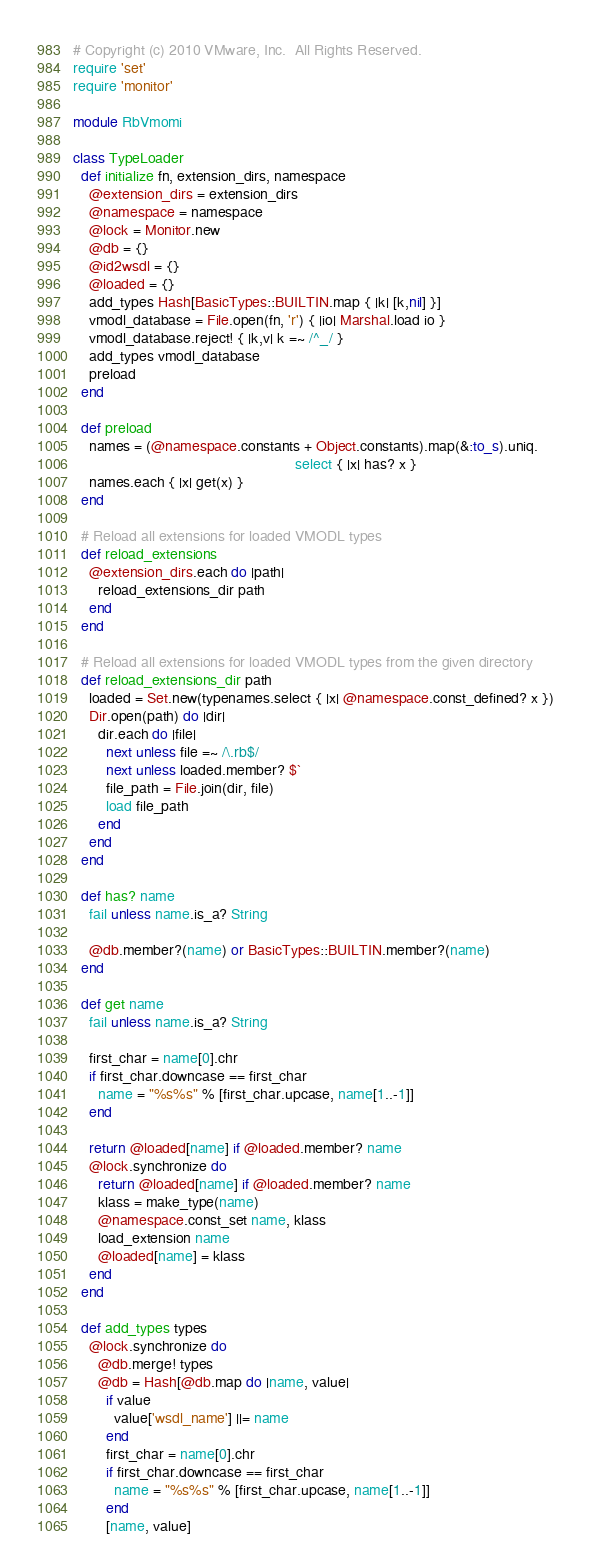Convert code to text. <code><loc_0><loc_0><loc_500><loc_500><_Ruby_># Copyright (c) 2010 VMware, Inc.  All Rights Reserved.
require 'set'
require 'monitor'

module RbVmomi

class TypeLoader
  def initialize fn, extension_dirs, namespace
    @extension_dirs = extension_dirs
    @namespace = namespace
    @lock = Monitor.new
    @db = {}
    @id2wsdl = {}
    @loaded = {}
    add_types Hash[BasicTypes::BUILTIN.map { |k| [k,nil] }]
    vmodl_database = File.open(fn, 'r') { |io| Marshal.load io }
    vmodl_database.reject! { |k,v| k =~ /^_/ }
    add_types vmodl_database
    preload
  end

  def preload
    names = (@namespace.constants + Object.constants).map(&:to_s).uniq.
                                                      select { |x| has? x }
    names.each { |x| get(x) }
  end

  # Reload all extensions for loaded VMODL types
  def reload_extensions
    @extension_dirs.each do |path|
      reload_extensions_dir path
    end
  end

  # Reload all extensions for loaded VMODL types from the given directory
  def reload_extensions_dir path
    loaded = Set.new(typenames.select { |x| @namespace.const_defined? x })
    Dir.open(path) do |dir|
      dir.each do |file|
        next unless file =~ /\.rb$/
        next unless loaded.member? $`
        file_path = File.join(dir, file)
        load file_path
      end
    end
  end

  def has? name
    fail unless name.is_a? String

    @db.member?(name) or BasicTypes::BUILTIN.member?(name)
  end

  def get name
    fail unless name.is_a? String

    first_char = name[0].chr
    if first_char.downcase == first_char
      name = "%s%s" % [first_char.upcase, name[1..-1]]
    end

    return @loaded[name] if @loaded.member? name
    @lock.synchronize do
      return @loaded[name] if @loaded.member? name
      klass = make_type(name)
      @namespace.const_set name, klass
      load_extension name
      @loaded[name] = klass
    end
  end

  def add_types types
    @lock.synchronize do
      @db.merge! types
      @db = Hash[@db.map do |name, value|
        if value
          value['wsdl_name'] ||= name
        end
        first_char = name[0].chr
        if first_char.downcase == first_char
          name = "%s%s" % [first_char.upcase, name[1..-1]]
        end
        [name, value]</code> 